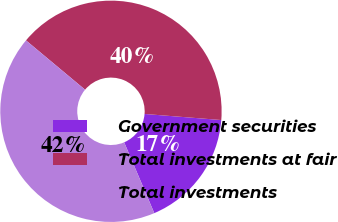Convert chart. <chart><loc_0><loc_0><loc_500><loc_500><pie_chart><fcel>Government securities<fcel>Total investments at fair<fcel>Total investments<nl><fcel>17.34%<fcel>40.19%<fcel>42.47%<nl></chart> 